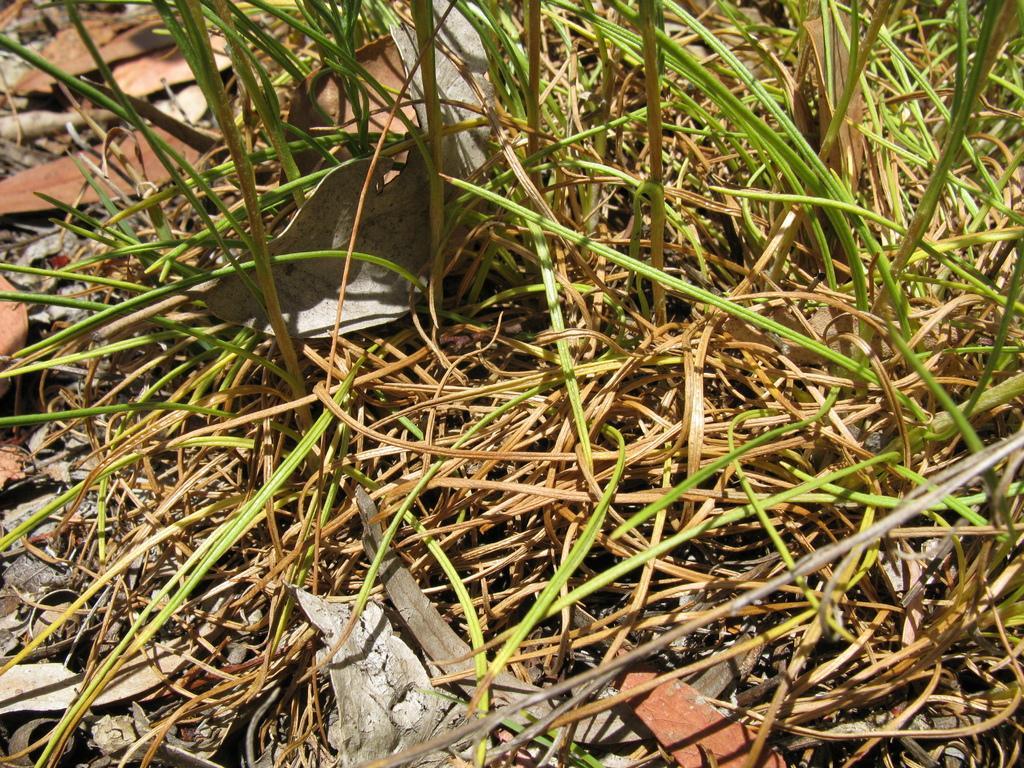In one or two sentences, can you explain what this image depicts? As we can see in the image there is grass and dry leaves. 